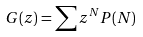<formula> <loc_0><loc_0><loc_500><loc_500>G ( z ) = \sum z ^ { N } P ( N )</formula> 